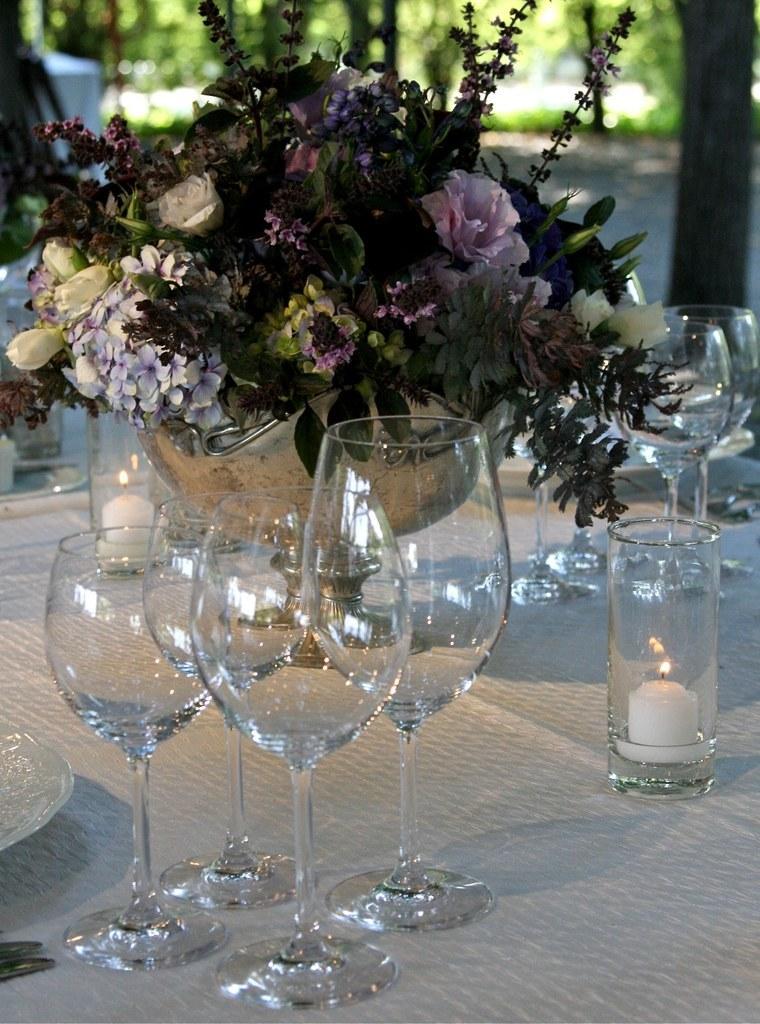Describe this image in one or two sentences. This image consists of a table on which there are glasses, candle, plate, knife, flower pot. There are so many kinds of flowers in this flower pot. 